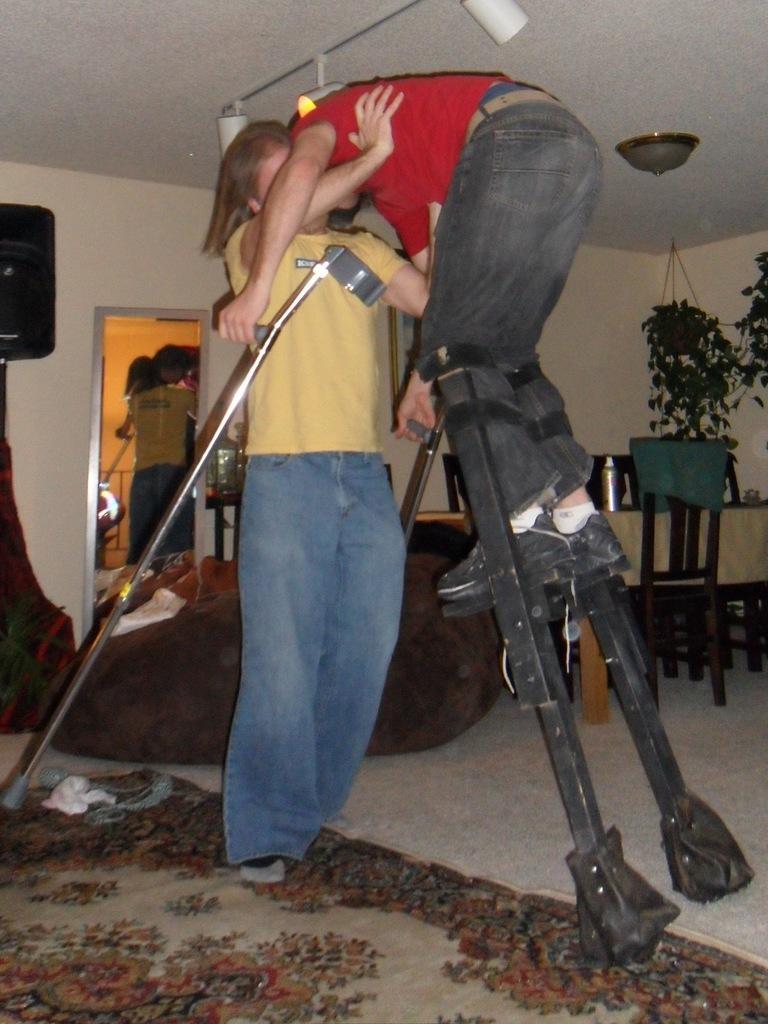How would you summarize this image in a sentence or two? In this image we can see two person. One is wearing yellow color t-shirt and jeans. And the other one is wearing red color t-shirt with black jeans and standing on the black color stand. behind the sofa, mirror, table, chair and plants are there. Bottom of the image carpet is there. The roof is in white color. 